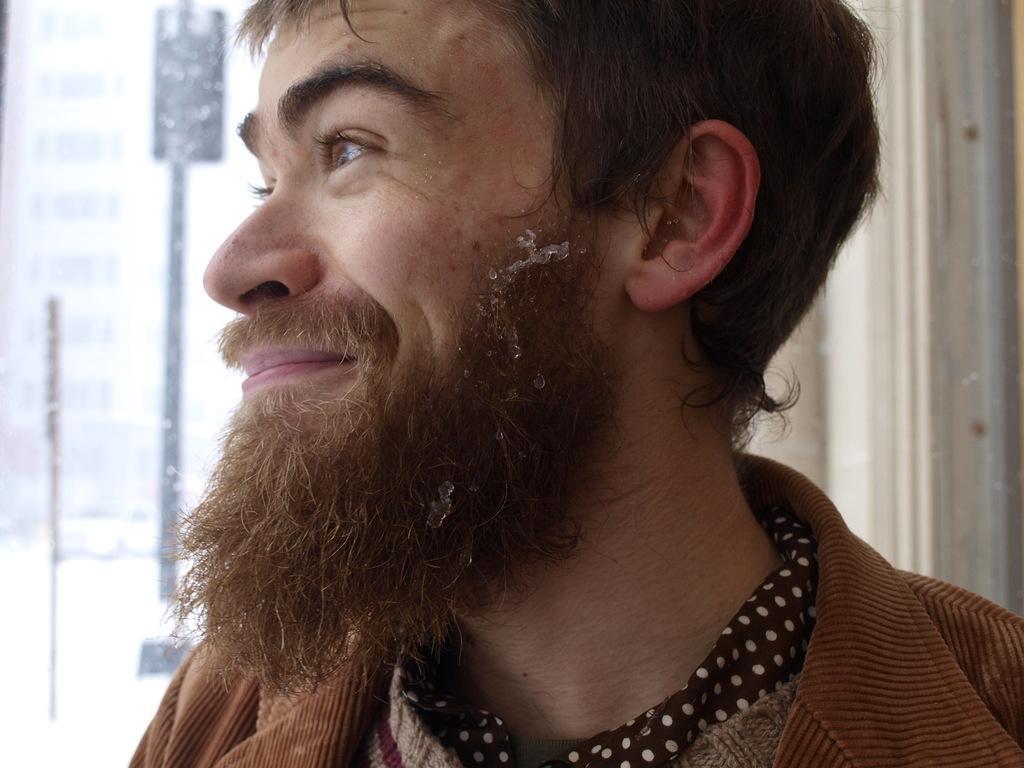Can you describe this image briefly? In the picture I can see a person wearing brown color jacket is having mustache and beard is smiling. The background of the image is slightly blurred, where we can see the glass windows. 